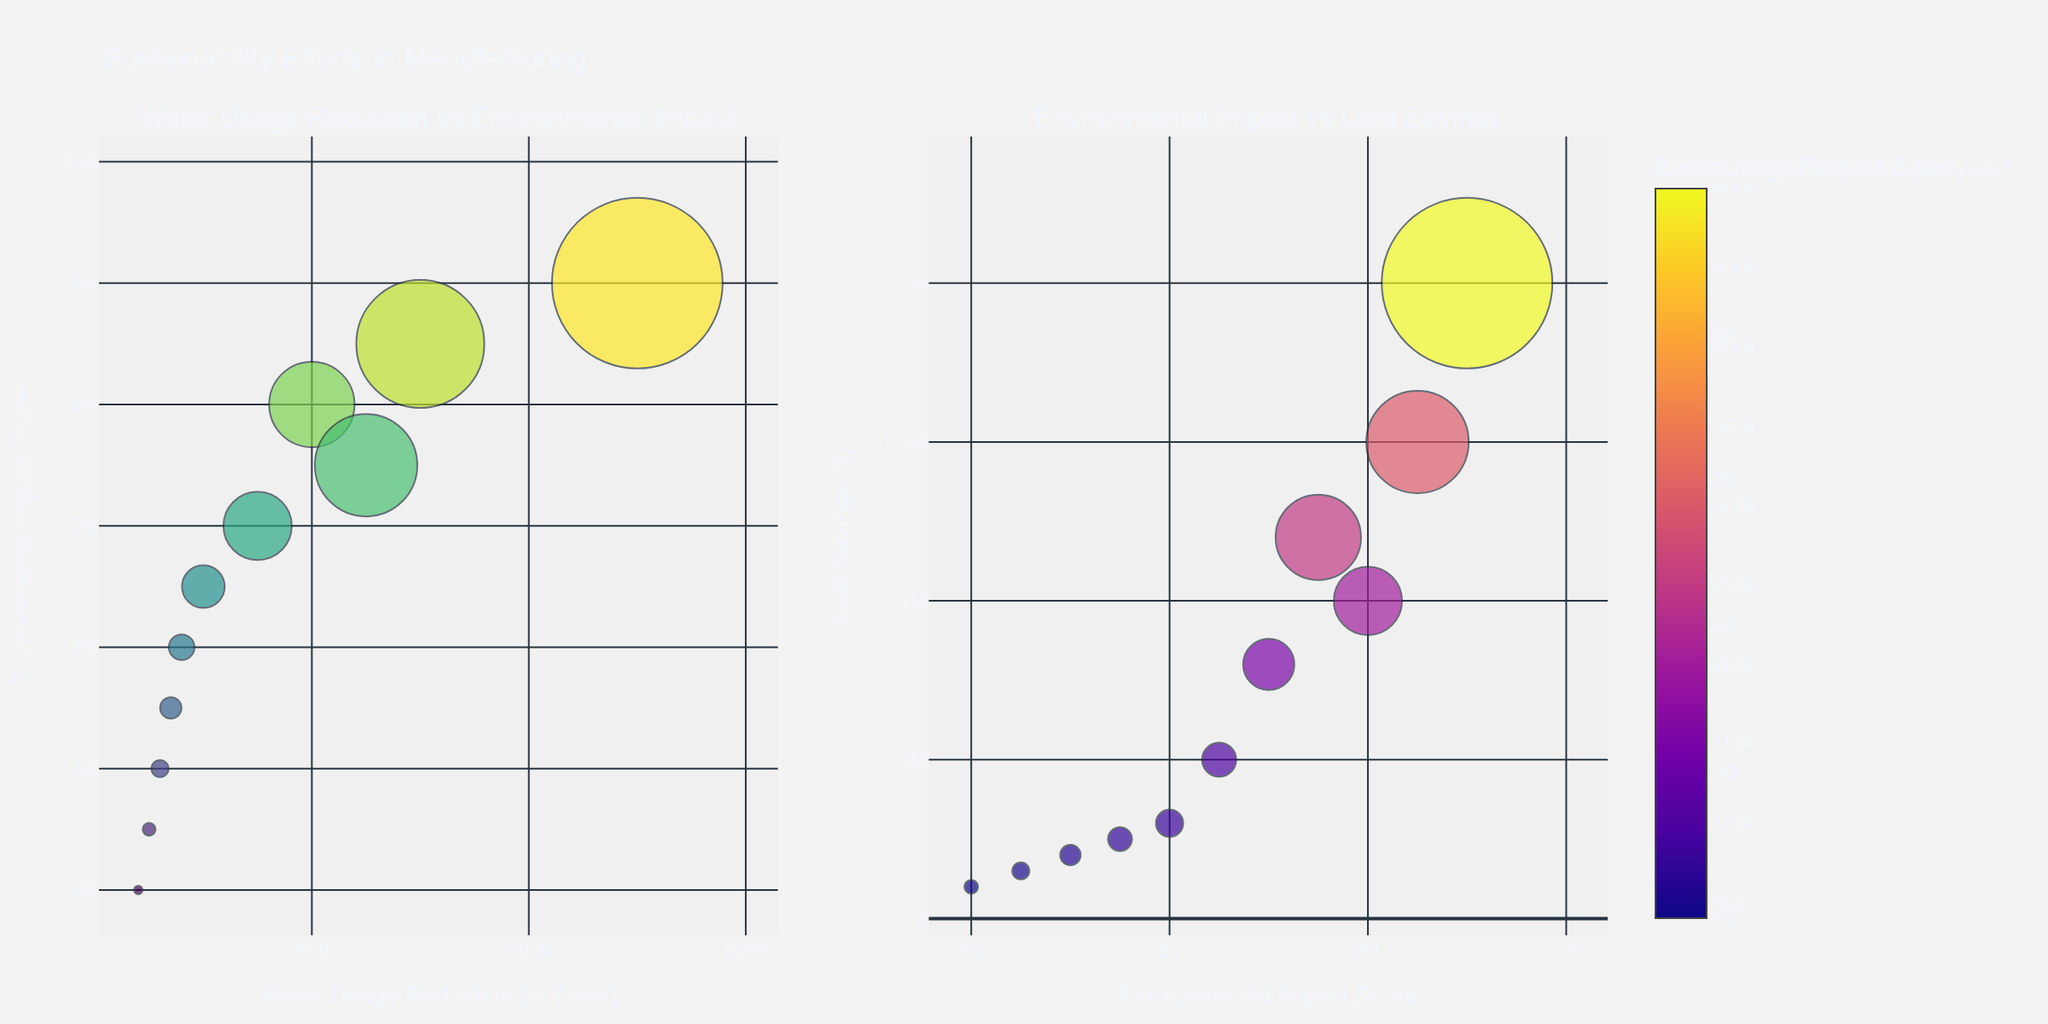What is the title of the figure? The title is typically positioned at the top of the figure and it summarizes the purpose of the plot.
Answer: Sustainability Efforts in Manufacturing How many companies are represented in the plot? Each bubble represents a company. Counting the distinct companies listed will give us the total number.
Answer: 11 Which company shows the highest water usage reduction? The bubble farthest to the right on the x-axis of the first subplot represents the highest water usage reduction.
Answer: Tesla Which manufacturing process has the highest environmental impact score? The highest environmental impact score can be found by looking at the bubble positioned highest on the y-axis in the first subplot.
Answer: Tesla's Gigafactory Battery Production What color represents the highest environmental impact score in the first subplot? The color scale on the right indicates the environmental impact score with different colors. The darkest color (usually in Viridis color scale) represents the highest score.
Answer: Darkest (towards yellow-green) Which company achieves the highest cost savings and what is the associated manufacturing process? The largest bubble in the second subplot represents the highest cost savings. The hovertext will provide the company and manufacturing process.
Answer: Tesla, Gigafactory Battery Production What is the environmental impact score of Apple’s smartphone production? Find the bubble labeled 'Apple' and check its y-axis position in the first subplot.
Answer: 70 Compare the water usage reduction and environmental impact score of Boeing and Unilever. Which company excels more in these metrics? Examine the positions of Boeing and Unilever in the first subplot. Unilever is further right (more water reduction) and has a higher y-axis value (higher environmental impact score).
Answer: Unilever Which company has the smallest water usage reduction and what is the exact value? The smallest bubble farthest to the left in the first subplot indicates the company with the smallest water usage reduction.
Answer: Nike, 40,000 cubic meters/year Is there any company that has an environmental impact score below 50? If so, name them. Check the bubbles in both subplots; any bubble below the horizontal line at y=50 in the first subplot fits this criterion.
Answer: Samsung, Nestle, and Nike What trend do you observe between environmental impact scores and cost savings in the second subplot? The second subplot shows environmental impact scores on the x-axis and cost savings on the y-axis. Typically, you'll observe whether higher scores tend to correlate with higher or lower cost savings.
Answer: General trend: Higher scores tend to correlate with higher cost savings 